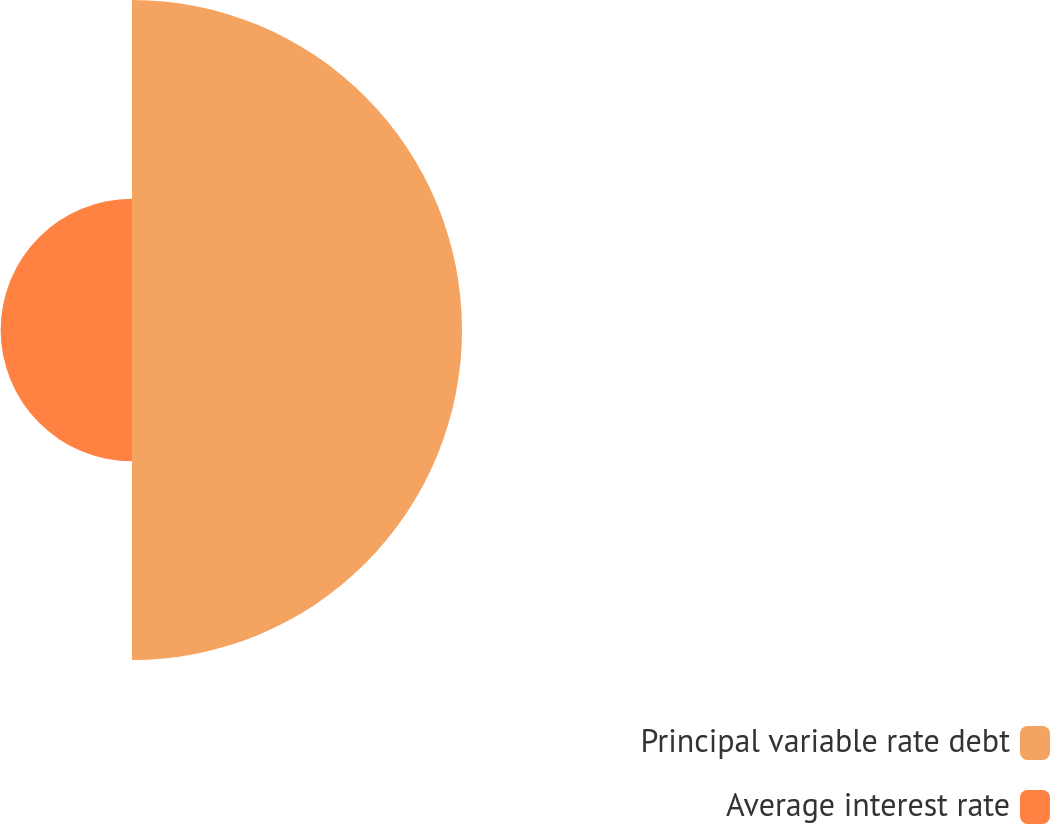<chart> <loc_0><loc_0><loc_500><loc_500><pie_chart><fcel>Principal variable rate debt<fcel>Average interest rate<nl><fcel>71.53%<fcel>28.47%<nl></chart> 